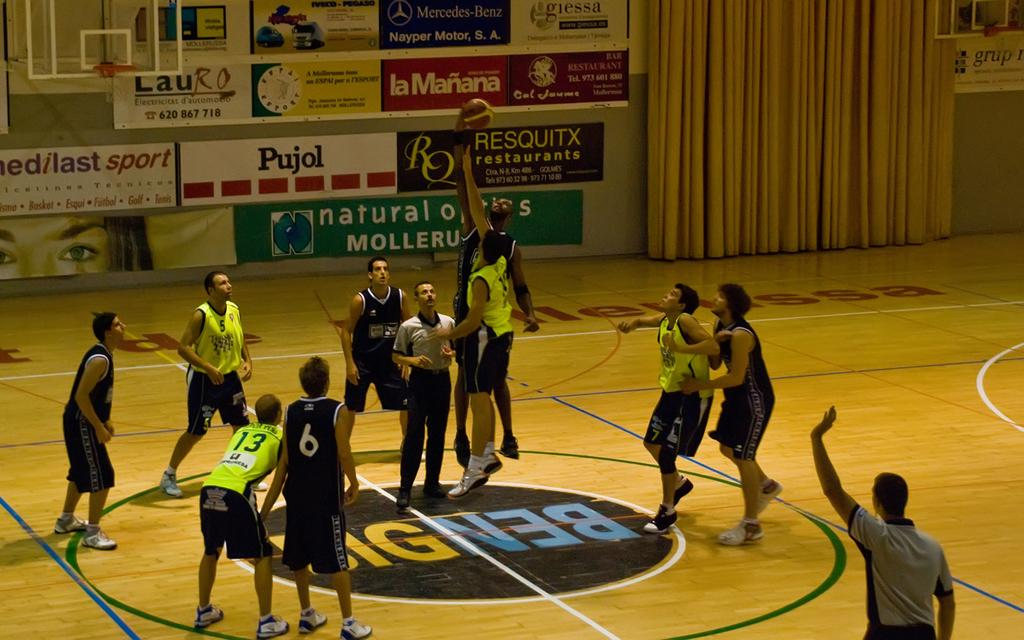What activity are the people in the image engaged in? The players in the image are playing basketball. What equipment is necessary for the game being played? There is a basketball hoop (basket) in the image, which is necessary for playing basketball. What can be seen in the background of the image? There are posters and curtains in the background of the image. What type of honey is being used to patch the hole in the image? There is no honey or hole present in the image. Where is the library located in the image? There is no library present in the image. 